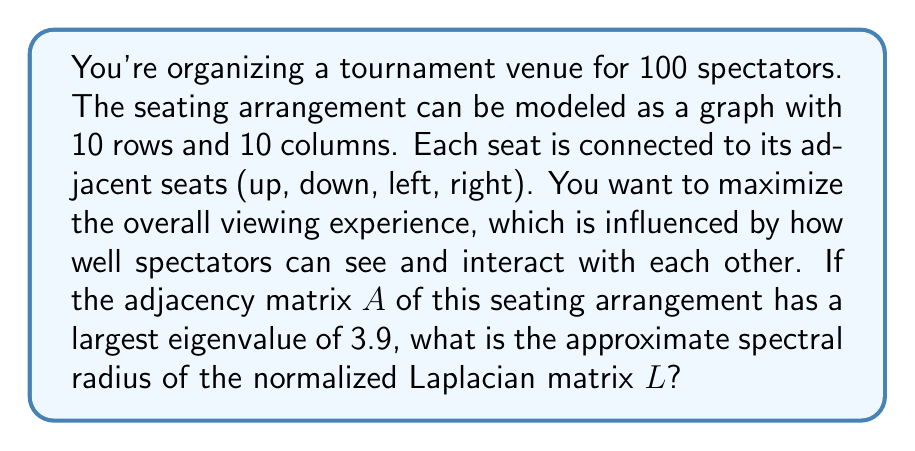Could you help me with this problem? Let's approach this step-by-step:

1) The adjacency matrix A represents the connections between seats. For an interior seat, it would have 4 connections (up, down, left, right).

2) The degree matrix D is a diagonal matrix where $D_{ii}$ is the degree (number of connections) of vertex i. For most seats, this would be 4, with some edge seats having 3 or 2 connections.

3) The normalized Laplacian matrix L is defined as:

   $$L = I - D^{-1/2}AD^{-1/2}$$

   where I is the identity matrix.

4) The spectral radius of a matrix is the maximum absolute value of its eigenvalues.

5) For the normalized Laplacian, we know that:
   - Its eigenvalues are between 0 and 2
   - The sum of its eigenvalues equals the number of vertices (100 in this case)
   - There's a relationship between the largest eigenvalue of A and the smallest non-zero eigenvalue of L

6) Specifically, if $\lambda_max(A)$ is the largest eigenvalue of A, then the second smallest eigenvalue of L, $\lambda_2(L)$, satisfies:

   $$\lambda_2(L) \geq 1 - \frac{\lambda_max(A)}{\Delta}$$

   where $\Delta$ is the maximum degree in the graph.

7) In our case, $\lambda_max(A) = 3.9$ and $\Delta = 4$

8) Therefore, $\lambda_2(L) \geq 1 - \frac{3.9}{4} = 0.025$

9) Given that the eigenvalues of L sum to 100, and they're all between 0 and 2, we can estimate that the largest eigenvalue of L is close to 2.

10) Thus, the spectral radius of L is approximately 2.
Answer: 2 